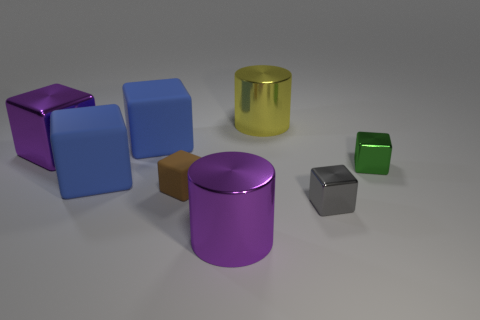Subtract all large rubber blocks. How many blocks are left? 4 Add 1 small purple rubber balls. How many objects exist? 9 Subtract all brown cylinders. How many blue cubes are left? 2 Subtract all gray cubes. How many cubes are left? 5 Subtract all cubes. How many objects are left? 2 Subtract 5 blocks. How many blocks are left? 1 Subtract all yellow cylinders. Subtract all yellow blocks. How many cylinders are left? 1 Subtract all tiny brown matte things. Subtract all big purple shiny cubes. How many objects are left? 6 Add 5 purple objects. How many purple objects are left? 7 Add 3 small brown things. How many small brown things exist? 4 